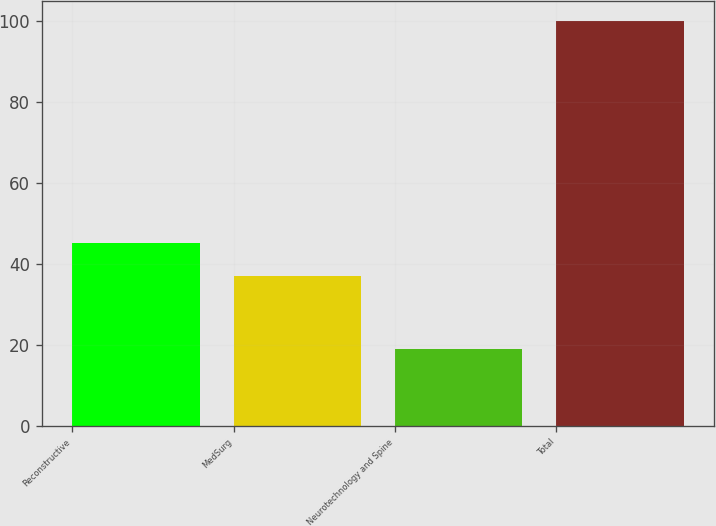Convert chart to OTSL. <chart><loc_0><loc_0><loc_500><loc_500><bar_chart><fcel>Reconstructive<fcel>MedSurg<fcel>Neurotechnology and Spine<fcel>Total<nl><fcel>45.1<fcel>37<fcel>19<fcel>100<nl></chart> 